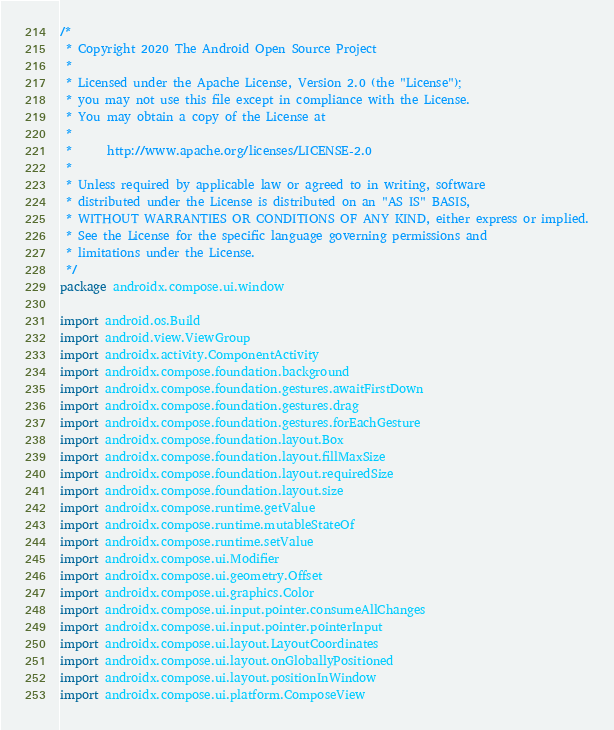Convert code to text. <code><loc_0><loc_0><loc_500><loc_500><_Kotlin_>/*
 * Copyright 2020 The Android Open Source Project
 *
 * Licensed under the Apache License, Version 2.0 (the "License");
 * you may not use this file except in compliance with the License.
 * You may obtain a copy of the License at
 *
 *      http://www.apache.org/licenses/LICENSE-2.0
 *
 * Unless required by applicable law or agreed to in writing, software
 * distributed under the License is distributed on an "AS IS" BASIS,
 * WITHOUT WARRANTIES OR CONDITIONS OF ANY KIND, either express or implied.
 * See the License for the specific language governing permissions and
 * limitations under the License.
 */
package androidx.compose.ui.window

import android.os.Build
import android.view.ViewGroup
import androidx.activity.ComponentActivity
import androidx.compose.foundation.background
import androidx.compose.foundation.gestures.awaitFirstDown
import androidx.compose.foundation.gestures.drag
import androidx.compose.foundation.gestures.forEachGesture
import androidx.compose.foundation.layout.Box
import androidx.compose.foundation.layout.fillMaxSize
import androidx.compose.foundation.layout.requiredSize
import androidx.compose.foundation.layout.size
import androidx.compose.runtime.getValue
import androidx.compose.runtime.mutableStateOf
import androidx.compose.runtime.setValue
import androidx.compose.ui.Modifier
import androidx.compose.ui.geometry.Offset
import androidx.compose.ui.graphics.Color
import androidx.compose.ui.input.pointer.consumeAllChanges
import androidx.compose.ui.input.pointer.pointerInput
import androidx.compose.ui.layout.LayoutCoordinates
import androidx.compose.ui.layout.onGloballyPositioned
import androidx.compose.ui.layout.positionInWindow
import androidx.compose.ui.platform.ComposeView</code> 